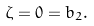Convert formula to latex. <formula><loc_0><loc_0><loc_500><loc_500>\zeta = 0 = b _ { 2 } .</formula> 